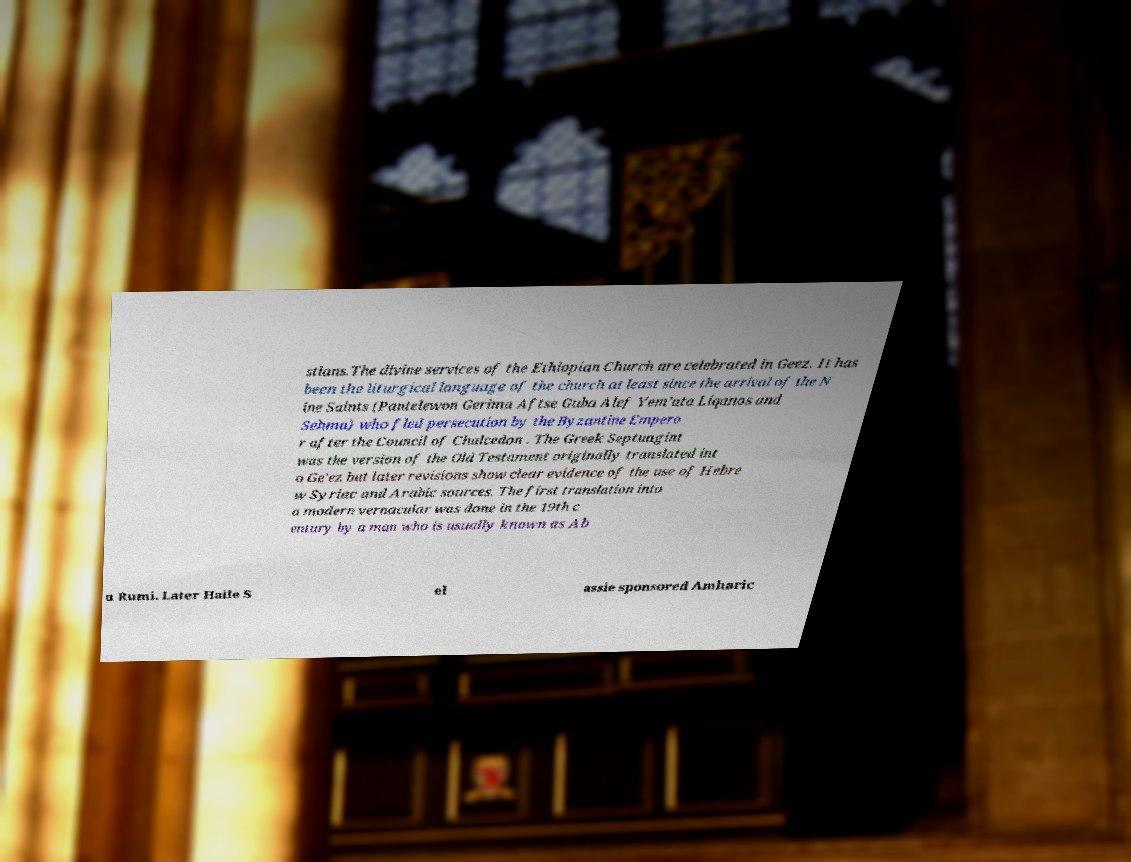Can you accurately transcribe the text from the provided image for me? stians.The divine services of the Ethiopian Church are celebrated in Geez. It has been the liturgical language of the church at least since the arrival of the N ine Saints (Pantelewon Gerima Aftse Guba Alef Yem’ata Liqanos and Sehma) who fled persecution by the Byzantine Empero r after the Council of Chalcedon . The Greek Septuagint was the version of the Old Testament originally translated int o Ge'ez but later revisions show clear evidence of the use of Hebre w Syriac and Arabic sources. The first translation into a modern vernacular was done in the 19th c entury by a man who is usually known as Ab u Rumi. Later Haile S el assie sponsored Amharic 